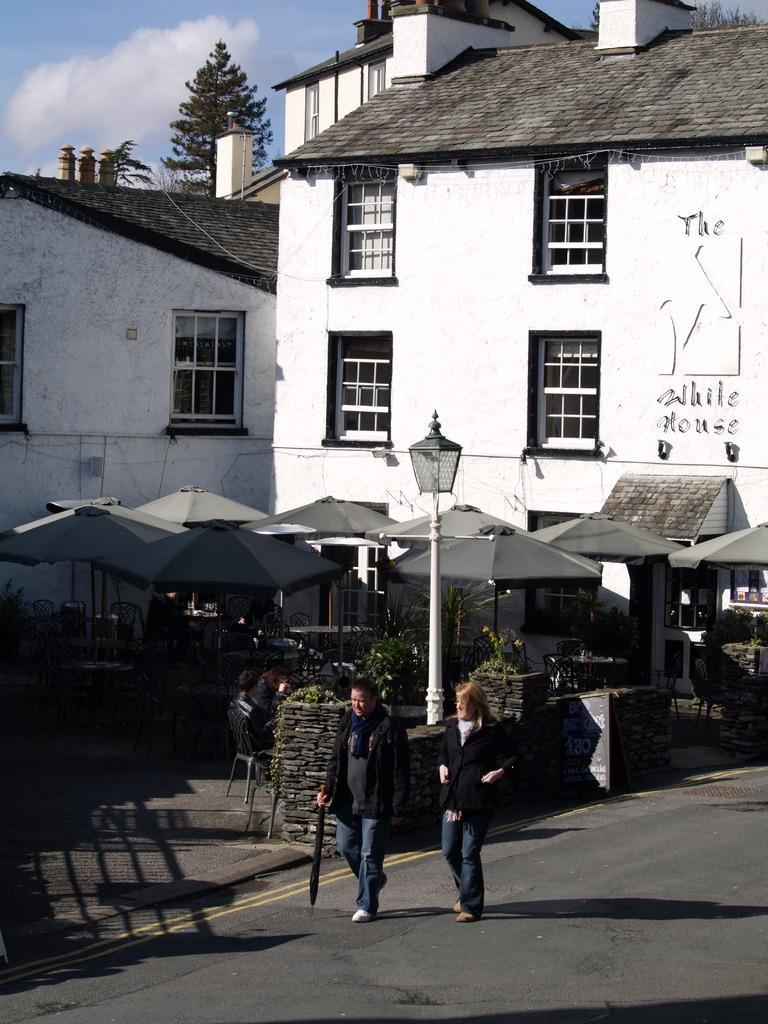Can you describe this image briefly? In the picture I can see people walking on the road. In the background I can see buildings, stalls, trees, the sky and some other objects. 